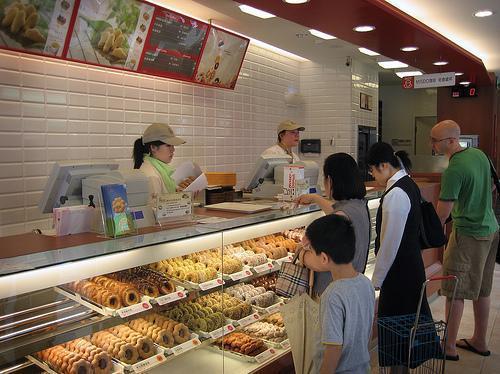How many customers are there?
Give a very brief answer. 4. 